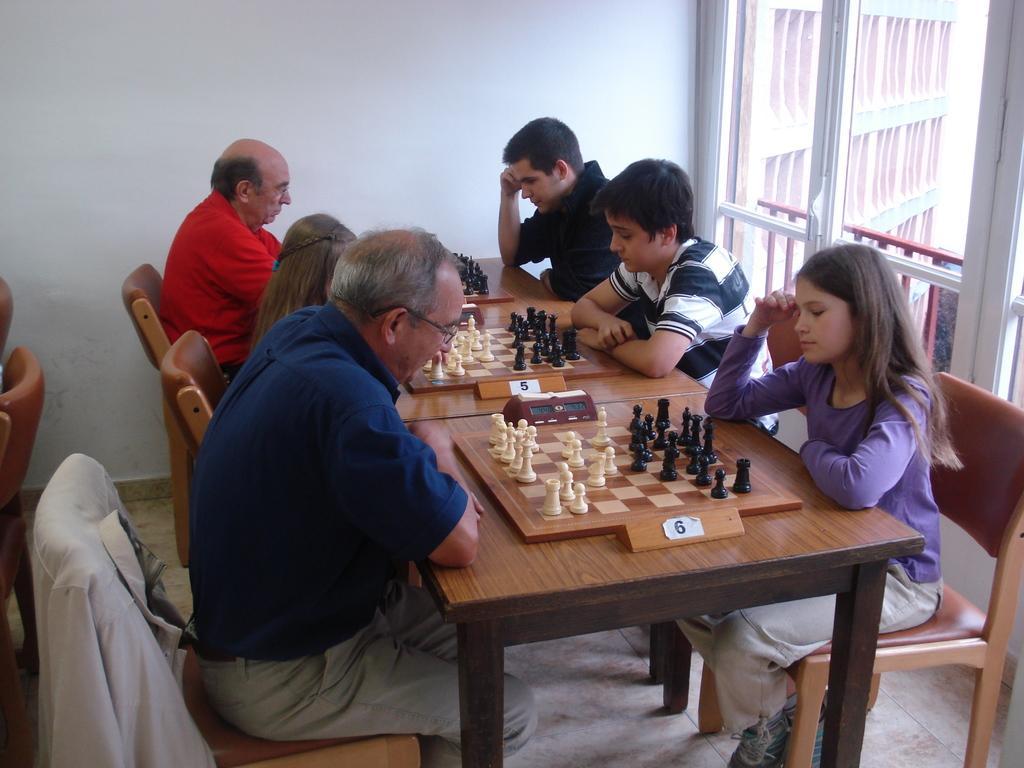In one or two sentences, can you explain what this image depicts? In this image there are six person sitting on the chair. On the table there is chess board. At the back side there is a wall and a window. 